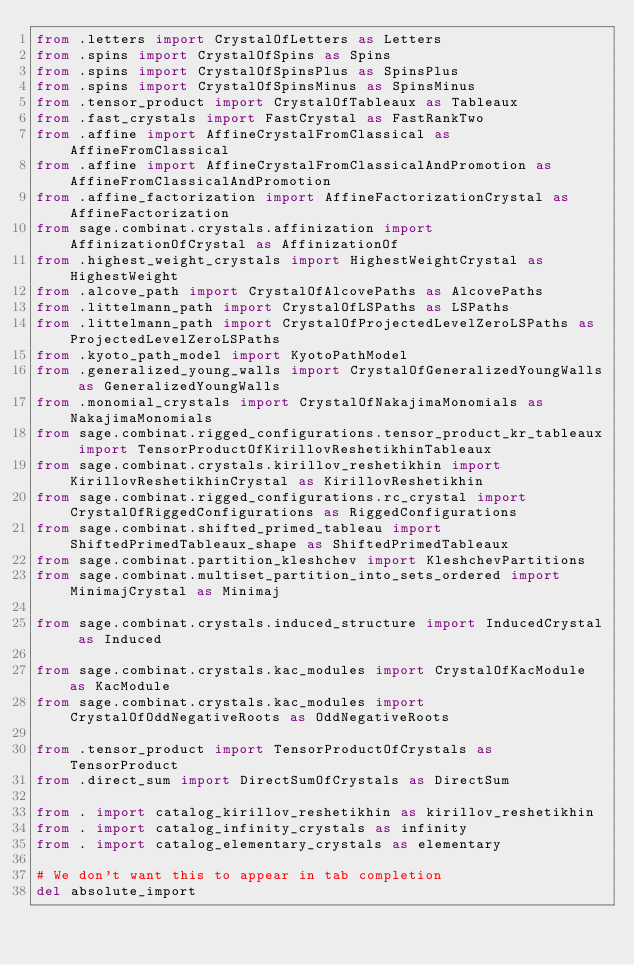Convert code to text. <code><loc_0><loc_0><loc_500><loc_500><_Python_>from .letters import CrystalOfLetters as Letters
from .spins import CrystalOfSpins as Spins
from .spins import CrystalOfSpinsPlus as SpinsPlus
from .spins import CrystalOfSpinsMinus as SpinsMinus
from .tensor_product import CrystalOfTableaux as Tableaux
from .fast_crystals import FastCrystal as FastRankTwo
from .affine import AffineCrystalFromClassical as AffineFromClassical
from .affine import AffineCrystalFromClassicalAndPromotion as AffineFromClassicalAndPromotion
from .affine_factorization import AffineFactorizationCrystal as AffineFactorization
from sage.combinat.crystals.affinization import AffinizationOfCrystal as AffinizationOf
from .highest_weight_crystals import HighestWeightCrystal as HighestWeight
from .alcove_path import CrystalOfAlcovePaths as AlcovePaths
from .littelmann_path import CrystalOfLSPaths as LSPaths
from .littelmann_path import CrystalOfProjectedLevelZeroLSPaths as ProjectedLevelZeroLSPaths
from .kyoto_path_model import KyotoPathModel
from .generalized_young_walls import CrystalOfGeneralizedYoungWalls as GeneralizedYoungWalls
from .monomial_crystals import CrystalOfNakajimaMonomials as NakajimaMonomials
from sage.combinat.rigged_configurations.tensor_product_kr_tableaux import TensorProductOfKirillovReshetikhinTableaux
from sage.combinat.crystals.kirillov_reshetikhin import KirillovReshetikhinCrystal as KirillovReshetikhin
from sage.combinat.rigged_configurations.rc_crystal import CrystalOfRiggedConfigurations as RiggedConfigurations
from sage.combinat.shifted_primed_tableau import ShiftedPrimedTableaux_shape as ShiftedPrimedTableaux
from sage.combinat.partition_kleshchev import KleshchevPartitions
from sage.combinat.multiset_partition_into_sets_ordered import MinimajCrystal as Minimaj

from sage.combinat.crystals.induced_structure import InducedCrystal as Induced

from sage.combinat.crystals.kac_modules import CrystalOfKacModule as KacModule
from sage.combinat.crystals.kac_modules import CrystalOfOddNegativeRoots as OddNegativeRoots

from .tensor_product import TensorProductOfCrystals as TensorProduct
from .direct_sum import DirectSumOfCrystals as DirectSum

from . import catalog_kirillov_reshetikhin as kirillov_reshetikhin
from . import catalog_infinity_crystals as infinity
from . import catalog_elementary_crystals as elementary

# We don't want this to appear in tab completion
del absolute_import
</code> 